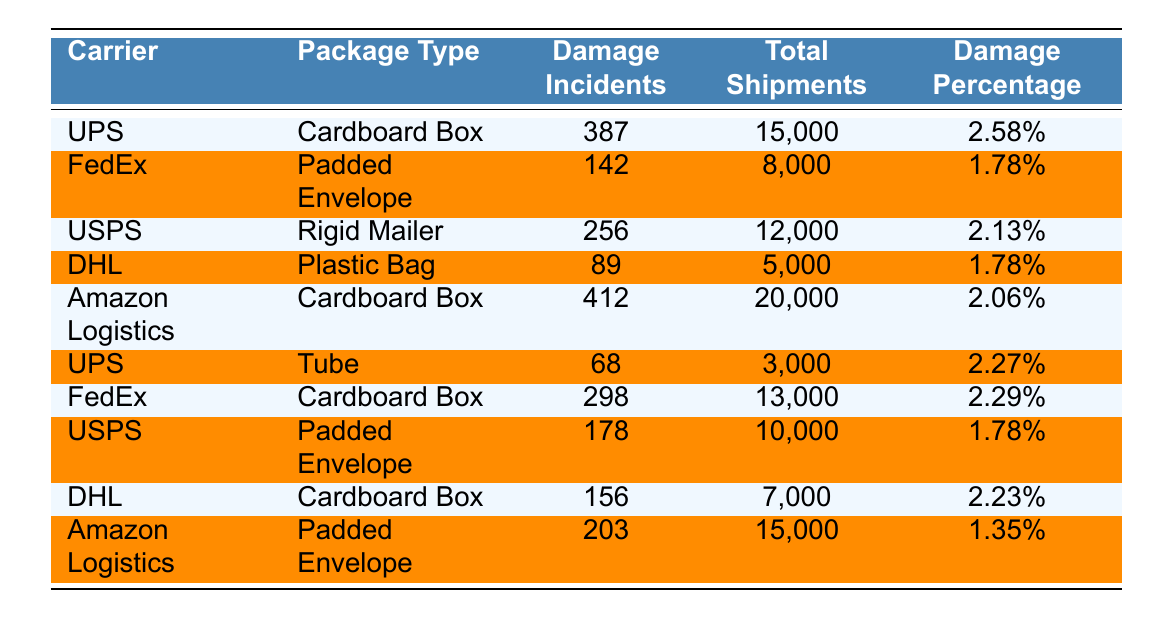What is the total number of damage incidents for all carriers? To find the total number of damage incidents, we need to sum the damage incidents for each carrier from the table: 387 (UPS, Cardboard Box) + 142 (FedEx, Padded Envelope) + 256 (USPS, Rigid Mailer) + 89 (DHL, Plastic Bag) + 412 (Amazon Logistics, Cardboard Box) + 68 (UPS, Tube) + 298 (FedEx, Cardboard Box) + 178 (USPS, Padded Envelope) + 156 (DHL, Cardboard Box) + 203 (Amazon Logistics, Padded Envelope) = 2019.
Answer: 2019 Which carrier has the highest damage percentage for package type "Cardboard Box"? By looking at the damage percentage for "Cardboard Box," UPS has a damage percentage of 2.58%, and Amazon Logistics has 2.06%. Since 2.58% is greater than 2.06%, UPS has the highest damage percentage for this package type.
Answer: UPS What is the damage percentage for FedEx using a Padded Envelope? The table shows that the damage percentage for FedEx when using a Padded Envelope is 1.78%.
Answer: 1.78% How many total shipments did DHL handle with Plastic Bags? The table indicates that DHL handled 5,000 shipments with Plastic Bags.
Answer: 5000 Which carrier and package type combination had the least damage incidents? Looking at the damage incidents, DHL with Plastic Bags had 89 incidents, which is the lowest. Hence, the combination is DHL and Plastic Bag.
Answer: DHL and Plastic Bag What is the average damage percentage for all package types handled by USPS? We take the damage percentages for USPS: 2.13% (Rigid Mailer) and 1.78% (Padded Envelope). To find the average: (2.13 + 1.78) / 2 = 1.955%.
Answer: 1.96% Is the damage percentage for Amazon Logistics using Padded Envelopes higher than that for FedEx using Padded Envelopes? Amazon Logistics has a damage percentage of 1.35% for Padded Envelopes and FedEx has 1.78%. Since 1.35% is less than 1.78%, it is false that Amazon Logistics has a higher damage percentage.
Answer: No What is the difference in damage incidents between FedEx and UPS for cardboard boxes? For FedEx's Cardboard Box, there are 298 damage incidents, while UPS has 387. The difference is 387 - 298 = 89.
Answer: 89 How many more total shipments did Amazon Logistics handle compared to DHL? Amazon Logistics had 20,000 total shipments, while DHL had 5,000. The difference is 20,000 - 5,000 = 15,000.
Answer: 15000 Which package type has the highest damage incidents overall? We can check the total damage incidents for each package type: Cardboard Box (387 + 412 + 156) = 955, Padded Envelope (142 + 178 + 203) = 523, Rigid Mailer (256), and Plastic Bag (89). Cardboard Box has the highest with 955 incidents.
Answer: Cardboard Box 